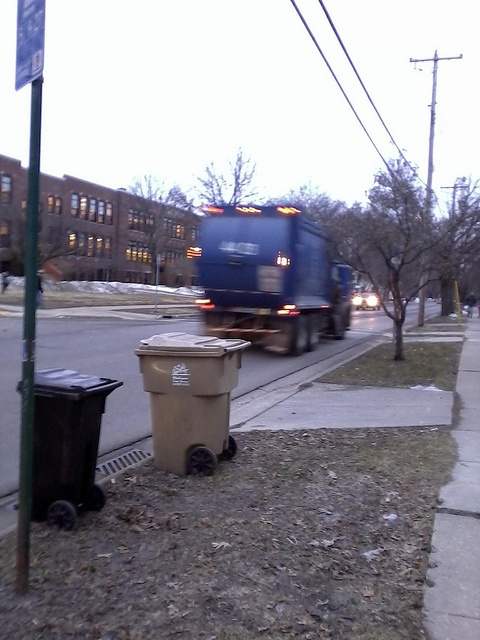Describe the objects in this image and their specific colors. I can see truck in white, navy, black, blue, and purple tones and car in white, darkgray, brown, and pink tones in this image. 